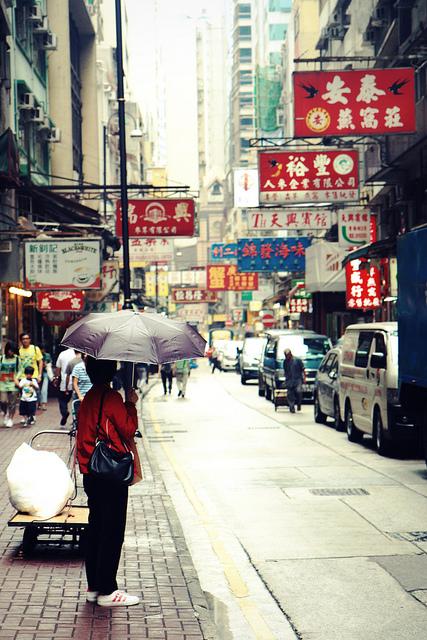On what continent is the woman standing?
Be succinct. Asia. Are there many people on the sidewalk?
Give a very brief answer. Yes. What is the woman holding above her head?
Give a very brief answer. Umbrella. 